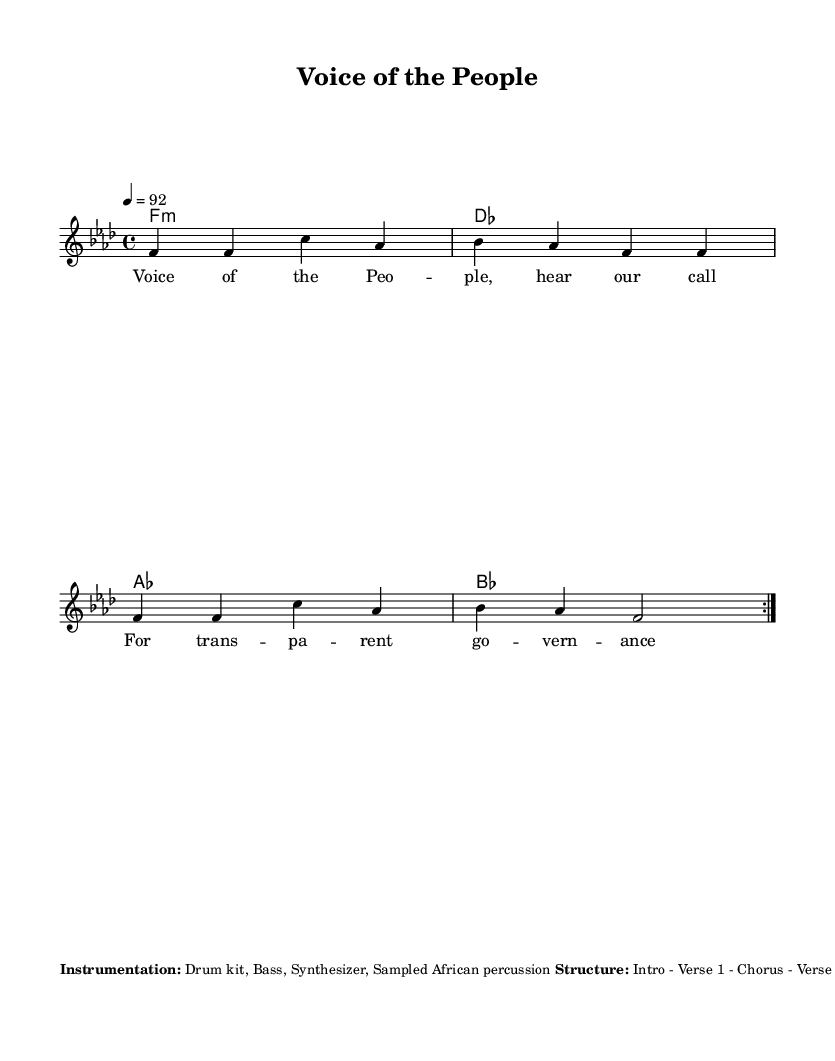What is the key signature of this music? The key signature is F minor, which consists of four flats. This can be found in the global section of the code where the key is declared.
Answer: F minor What is the time signature of the piece? The time signature is 4/4, indicating four beats per measure. This is specified in the global section of the code.
Answer: 4/4 What is the tempo marking for the music? The tempo is indicated as 92 beats per minute, found in the global settings of the music.
Answer: 92 How many measures are in the repeating section? There are four measures in the repeating section of the melody, as indicated by the use of the repeat volta markings in the melody definition.
Answer: Four What type of rhythm is used for the bass? The bass rhythm is syncopated eighth notes, which is specified in the additional elements section of the markup.
Answer: Syncopated eighth notes Which traditional instruments are included in the instrumentation? The instrumentation includes a drum kit, bass, synthesizer, and sampled African percussion, as stated in the markup.
Answer: Drum kit, Bass, Synthesizer, Sampled African percussion What is a major theme presented in the lyrics? A major theme in the lyrics is the call for transparent governance, directly stated in the lyrical themes of the markup.
Answer: Transparent governance 